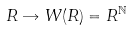<formula> <loc_0><loc_0><loc_500><loc_500>R \rightarrow W ( R ) = R ^ { \mathbb { N } }</formula> 